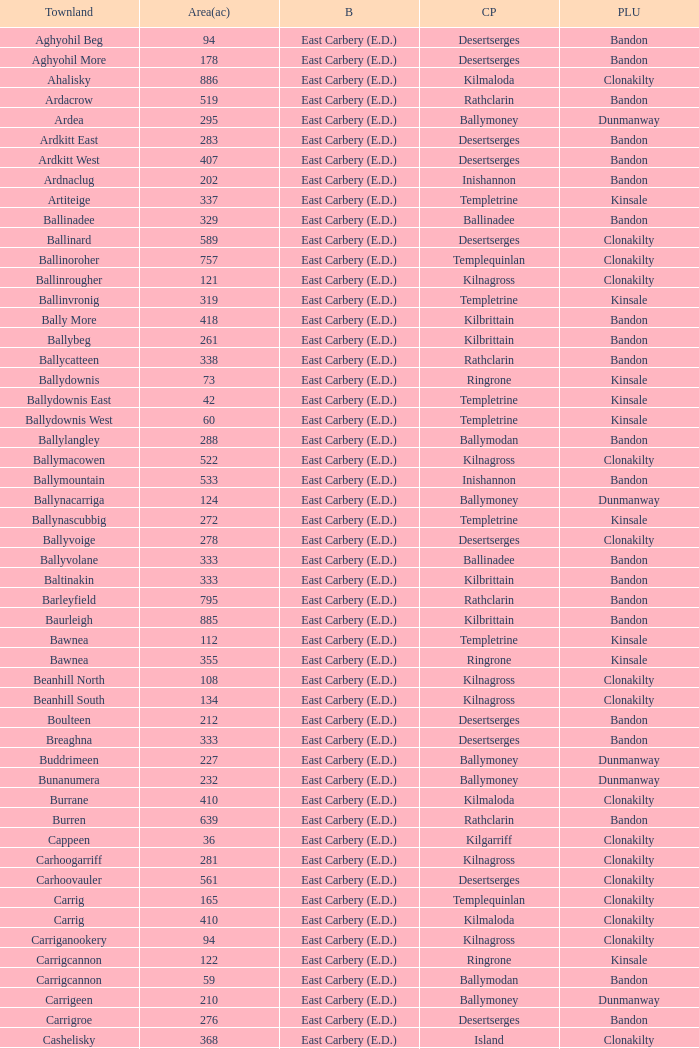What is the maximum area (in acres) of the Knockacullen townland? 381.0. 